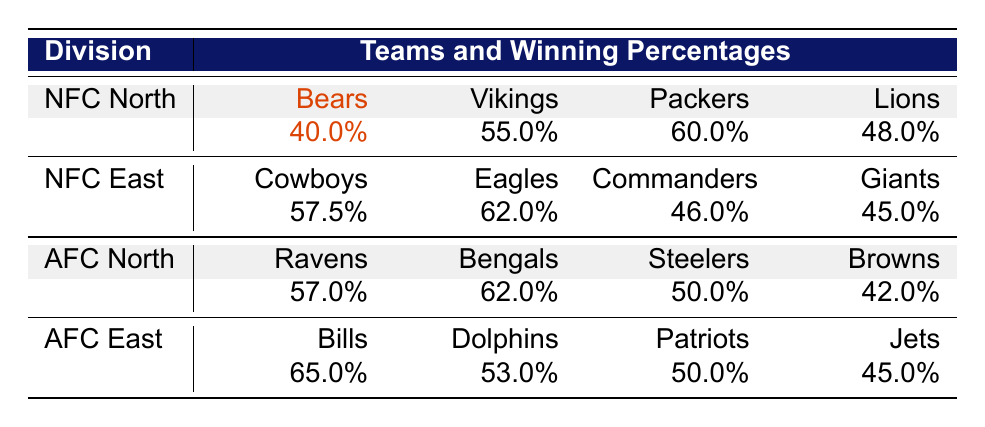What is the winning percentage of the Chicago Bears? The table specifies the winning percentage of the Chicago Bears directly in the NFC North section, which is listed as 40.0%.
Answer: 40.0% Which team has the highest winning percentage in the AFC North? In the AFC North section of the table, the winning percentages are 57.0% for the Ravens, 62.0% for the Bengals, 50.0% for the Steelers, and 42.0% for the Browns. The Bengals have the highest winning percentage at 62.0%.
Answer: 62.0% Is the winning percentage of the Detroit Lions higher than that of the New York Giants? The winning percentage for the Detroit Lions is 48.0% and for the New York Giants is 45.0%. Since 48.0% is greater than 45.0%, the statement is true.
Answer: Yes What is the average winning percentage of all teams in the NFC East? The winning percentages for the NFC East teams are 57.5%, 62.0%, 46.0%, and 45.0%. To find the average, we sum them up: 57.5 + 62.0 + 46.0 + 45.0 = 210.5. Then divide by the number of teams, which is 4. Therefore, the average is 210.5 / 4 = 52.625%.
Answer: 52.625% Which division has the lowest average winning percentage? First, we calculate the average for each division: NFC North has (40.0 + 55.0 + 60.0 + 48.0) / 4 = 51.25%. NFC East has (57.5 + 62.0 + 46.0 + 45.0) / 4 = 52.625%. AFC North has (57.0 + 62.0 + 50.0 + 42.0) / 4 = 52.25%. AFC East has (65.0 + 53.0 + 50.0 + 45.0) / 4 = 53.25%. Comparing these averages, the NFC North has the lowest average winning percentage at 51.25%.
Answer: NFC North Is it true that the winning percentage of the Minnesota Vikings is equal to that of the Cleveland Browns? The winning percentage for the Minnesota Vikings is 55.0% and for the Cleveland Browns is 42.0%. Since 55.0% is not equal to 42.0%, the statement is false.
Answer: No 